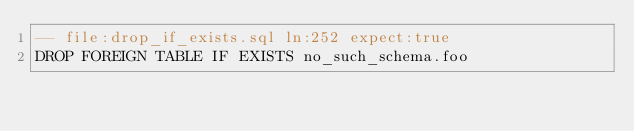<code> <loc_0><loc_0><loc_500><loc_500><_SQL_>-- file:drop_if_exists.sql ln:252 expect:true
DROP FOREIGN TABLE IF EXISTS no_such_schema.foo
</code> 